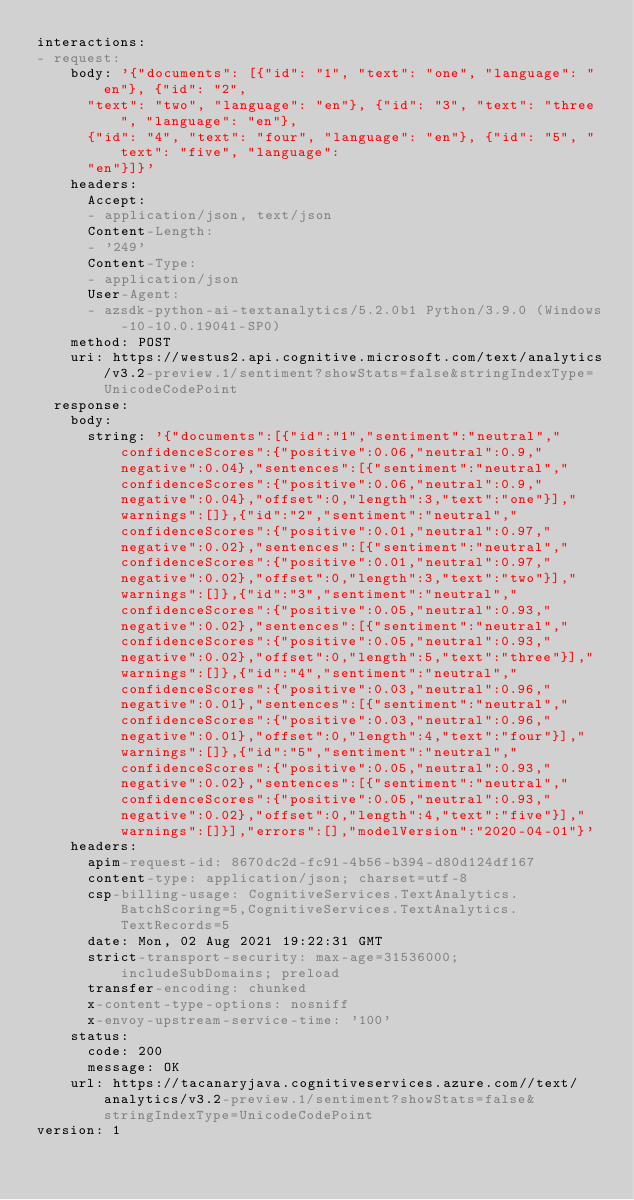Convert code to text. <code><loc_0><loc_0><loc_500><loc_500><_YAML_>interactions:
- request:
    body: '{"documents": [{"id": "1", "text": "one", "language": "en"}, {"id": "2",
      "text": "two", "language": "en"}, {"id": "3", "text": "three", "language": "en"},
      {"id": "4", "text": "four", "language": "en"}, {"id": "5", "text": "five", "language":
      "en"}]}'
    headers:
      Accept:
      - application/json, text/json
      Content-Length:
      - '249'
      Content-Type:
      - application/json
      User-Agent:
      - azsdk-python-ai-textanalytics/5.2.0b1 Python/3.9.0 (Windows-10-10.0.19041-SP0)
    method: POST
    uri: https://westus2.api.cognitive.microsoft.com/text/analytics/v3.2-preview.1/sentiment?showStats=false&stringIndexType=UnicodeCodePoint
  response:
    body:
      string: '{"documents":[{"id":"1","sentiment":"neutral","confidenceScores":{"positive":0.06,"neutral":0.9,"negative":0.04},"sentences":[{"sentiment":"neutral","confidenceScores":{"positive":0.06,"neutral":0.9,"negative":0.04},"offset":0,"length":3,"text":"one"}],"warnings":[]},{"id":"2","sentiment":"neutral","confidenceScores":{"positive":0.01,"neutral":0.97,"negative":0.02},"sentences":[{"sentiment":"neutral","confidenceScores":{"positive":0.01,"neutral":0.97,"negative":0.02},"offset":0,"length":3,"text":"two"}],"warnings":[]},{"id":"3","sentiment":"neutral","confidenceScores":{"positive":0.05,"neutral":0.93,"negative":0.02},"sentences":[{"sentiment":"neutral","confidenceScores":{"positive":0.05,"neutral":0.93,"negative":0.02},"offset":0,"length":5,"text":"three"}],"warnings":[]},{"id":"4","sentiment":"neutral","confidenceScores":{"positive":0.03,"neutral":0.96,"negative":0.01},"sentences":[{"sentiment":"neutral","confidenceScores":{"positive":0.03,"neutral":0.96,"negative":0.01},"offset":0,"length":4,"text":"four"}],"warnings":[]},{"id":"5","sentiment":"neutral","confidenceScores":{"positive":0.05,"neutral":0.93,"negative":0.02},"sentences":[{"sentiment":"neutral","confidenceScores":{"positive":0.05,"neutral":0.93,"negative":0.02},"offset":0,"length":4,"text":"five"}],"warnings":[]}],"errors":[],"modelVersion":"2020-04-01"}'
    headers:
      apim-request-id: 8670dc2d-fc91-4b56-b394-d80d124df167
      content-type: application/json; charset=utf-8
      csp-billing-usage: CognitiveServices.TextAnalytics.BatchScoring=5,CognitiveServices.TextAnalytics.TextRecords=5
      date: Mon, 02 Aug 2021 19:22:31 GMT
      strict-transport-security: max-age=31536000; includeSubDomains; preload
      transfer-encoding: chunked
      x-content-type-options: nosniff
      x-envoy-upstream-service-time: '100'
    status:
      code: 200
      message: OK
    url: https://tacanaryjava.cognitiveservices.azure.com//text/analytics/v3.2-preview.1/sentiment?showStats=false&stringIndexType=UnicodeCodePoint
version: 1
</code> 